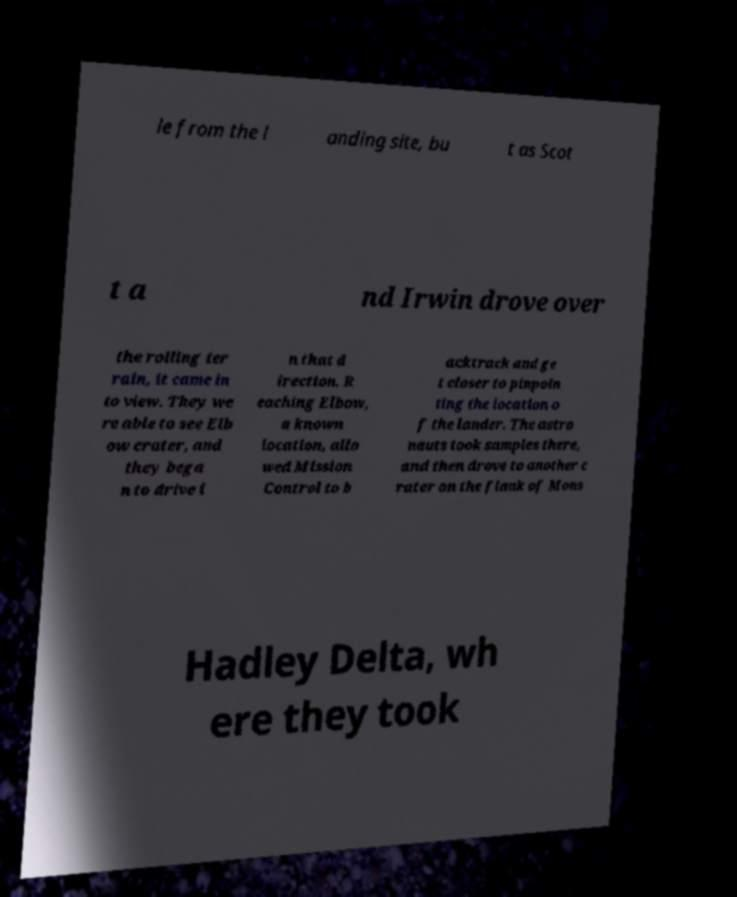I need the written content from this picture converted into text. Can you do that? le from the l anding site, bu t as Scot t a nd Irwin drove over the rolling ter rain, it came in to view. They we re able to see Elb ow crater, and they bega n to drive i n that d irection. R eaching Elbow, a known location, allo wed Mission Control to b acktrack and ge t closer to pinpoin ting the location o f the lander. The astro nauts took samples there, and then drove to another c rater on the flank of Mons Hadley Delta, wh ere they took 